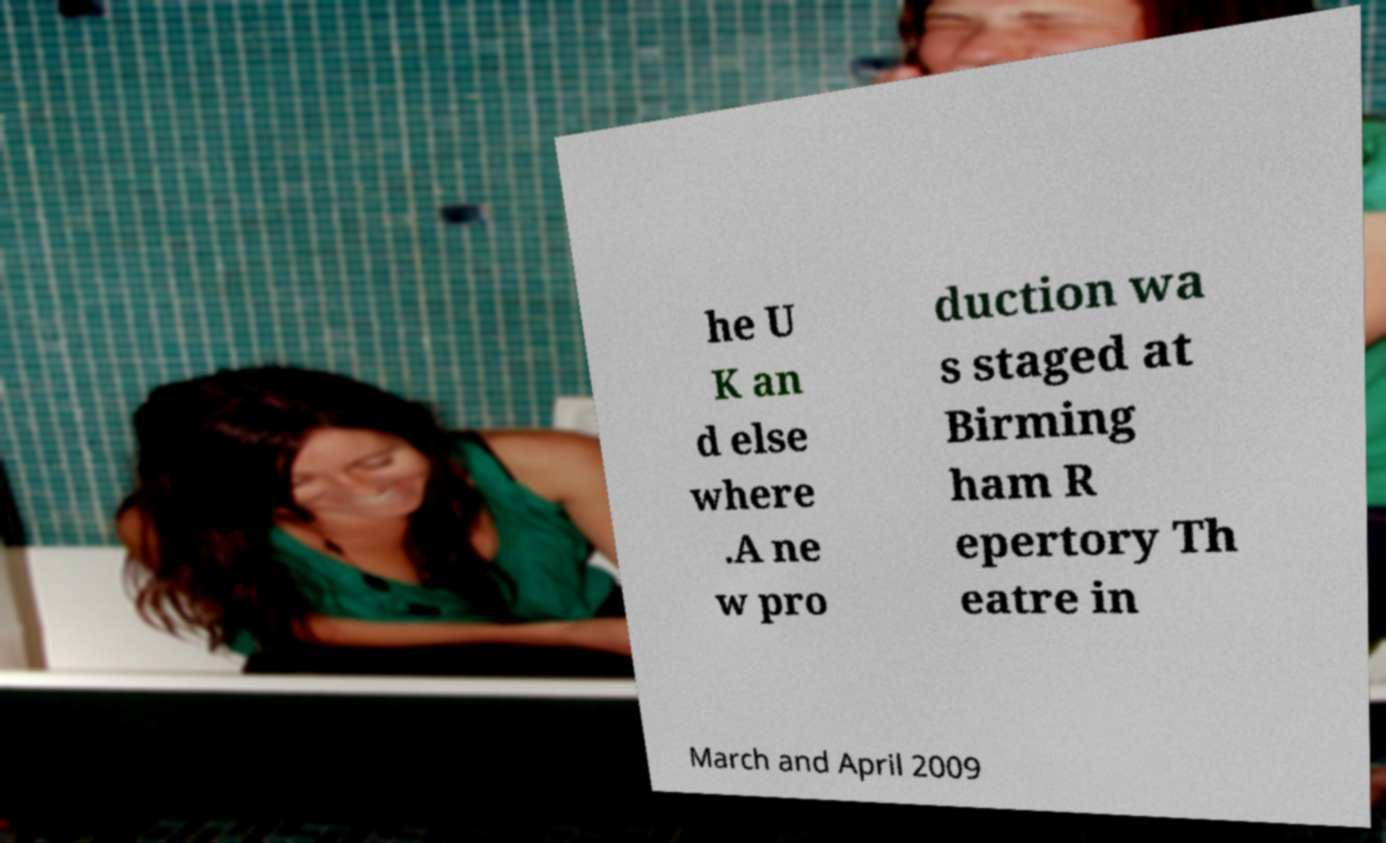Can you accurately transcribe the text from the provided image for me? he U K an d else where .A ne w pro duction wa s staged at Birming ham R epertory Th eatre in March and April 2009 